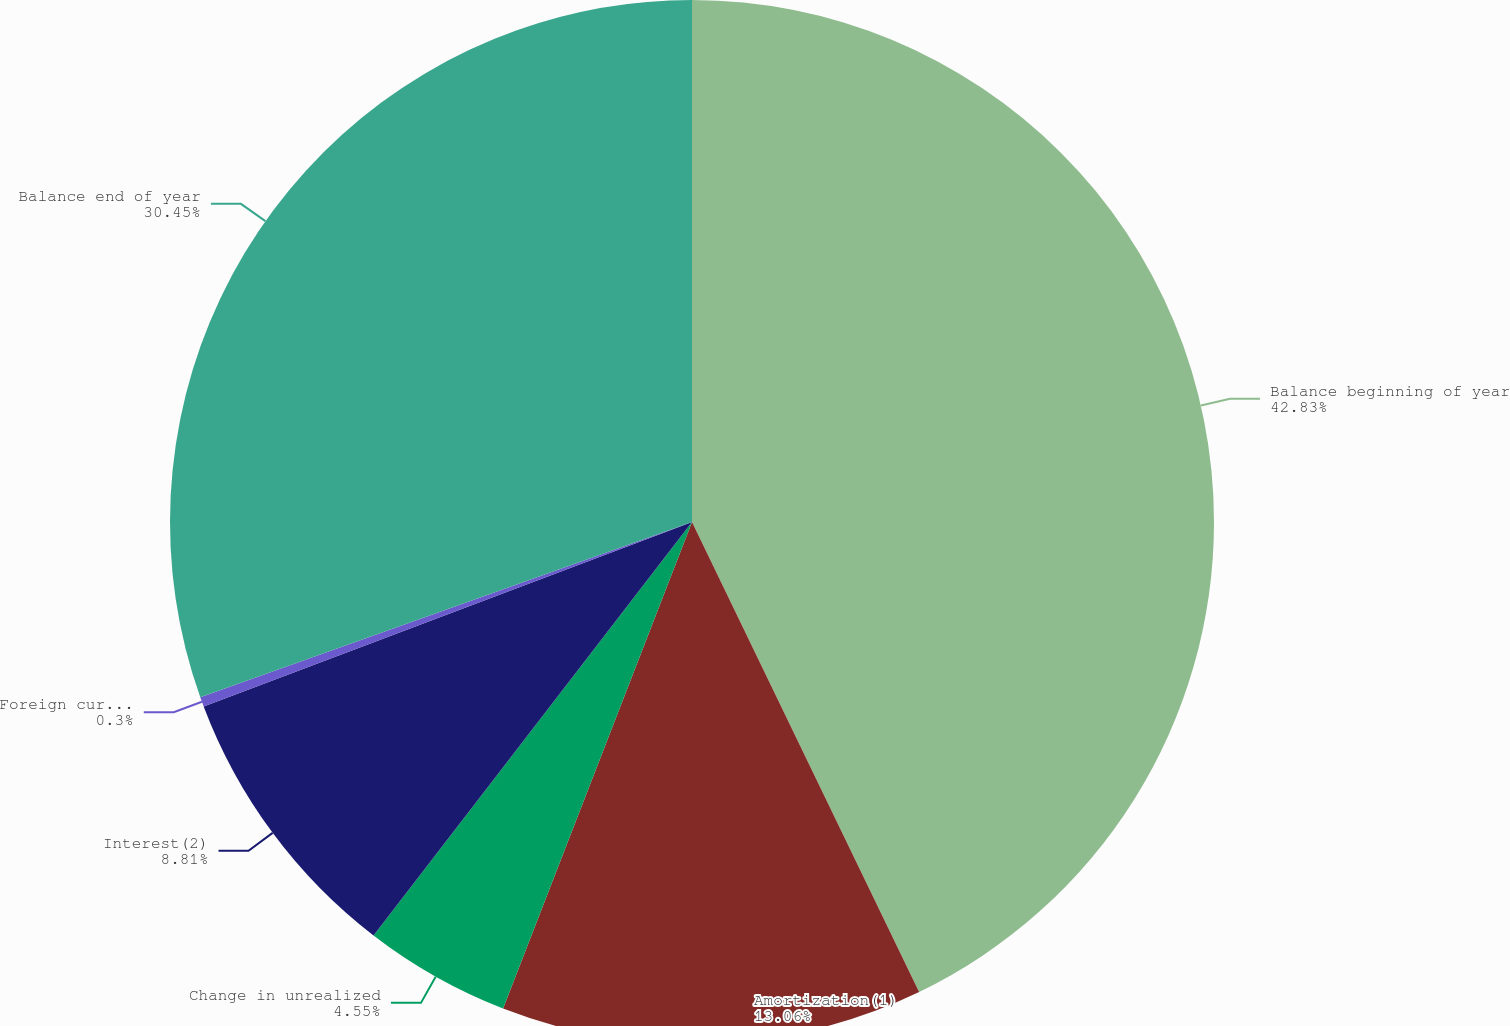Convert chart to OTSL. <chart><loc_0><loc_0><loc_500><loc_500><pie_chart><fcel>Balance beginning of year<fcel>Amortization(1)<fcel>Change in unrealized<fcel>Interest(2)<fcel>Foreign currency translation<fcel>Balance end of year<nl><fcel>42.84%<fcel>13.06%<fcel>4.55%<fcel>8.81%<fcel>0.3%<fcel>30.45%<nl></chart> 